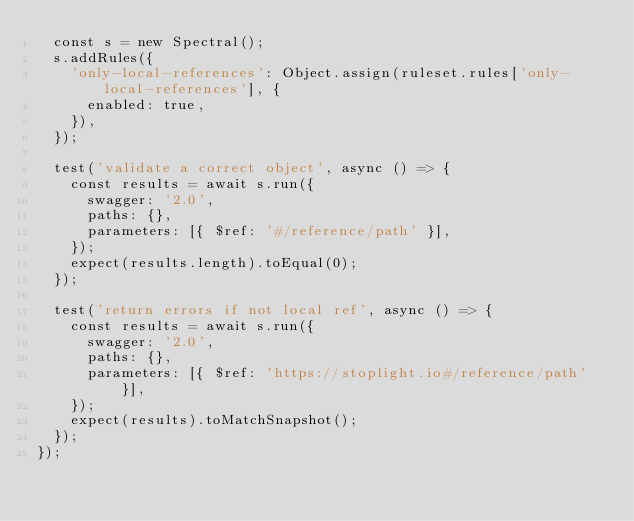<code> <loc_0><loc_0><loc_500><loc_500><_TypeScript_>  const s = new Spectral();
  s.addRules({
    'only-local-references': Object.assign(ruleset.rules['only-local-references'], {
      enabled: true,
    }),
  });

  test('validate a correct object', async () => {
    const results = await s.run({
      swagger: '2.0',
      paths: {},
      parameters: [{ $ref: '#/reference/path' }],
    });
    expect(results.length).toEqual(0);
  });

  test('return errors if not local ref', async () => {
    const results = await s.run({
      swagger: '2.0',
      paths: {},
      parameters: [{ $ref: 'https://stoplight.io#/reference/path' }],
    });
    expect(results).toMatchSnapshot();
  });
});
</code> 